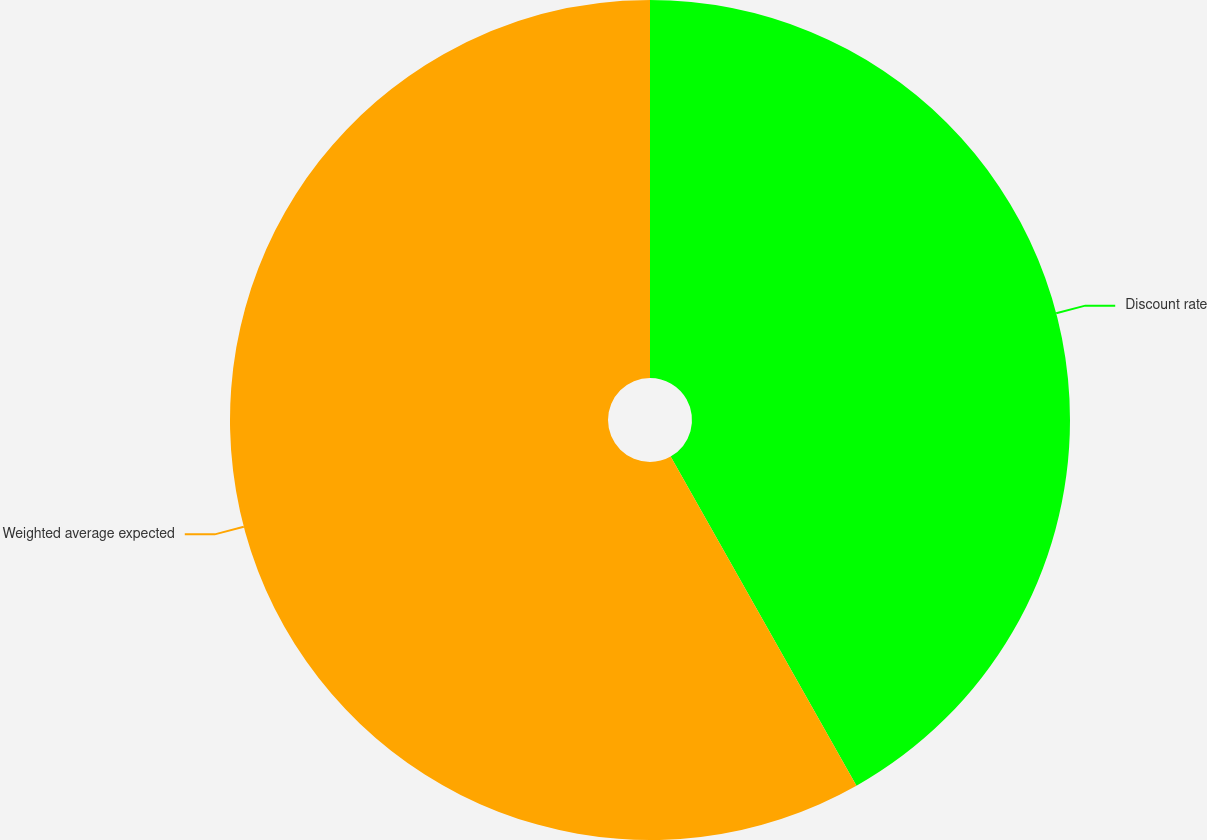Convert chart to OTSL. <chart><loc_0><loc_0><loc_500><loc_500><pie_chart><fcel>Discount rate<fcel>Weighted average expected<nl><fcel>41.82%<fcel>58.18%<nl></chart> 